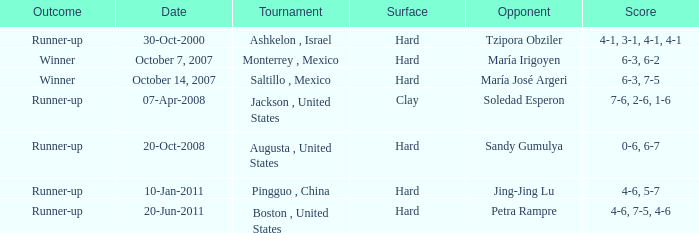Which tournament was held on October 14, 2007? Saltillo , Mexico. 